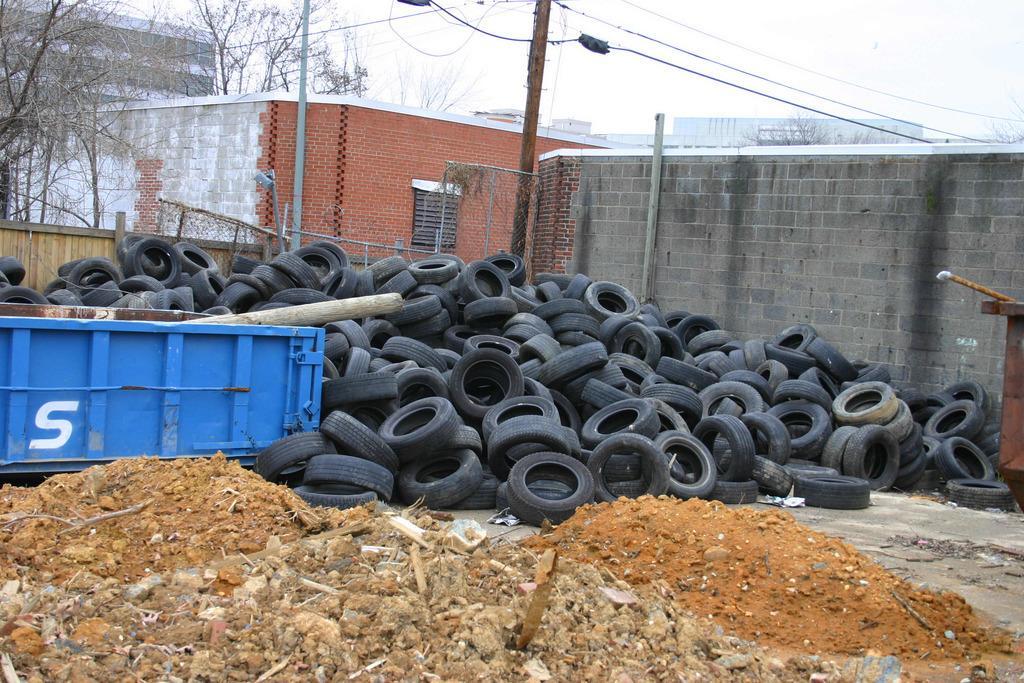Could you give a brief overview of what you see in this image? In this image I can see few wheels, mud, wooden sticks on the floor. I can also see a blue color vehicle, background I can see few buildings in gray and brown color, an electric pole and the sky is in white color 